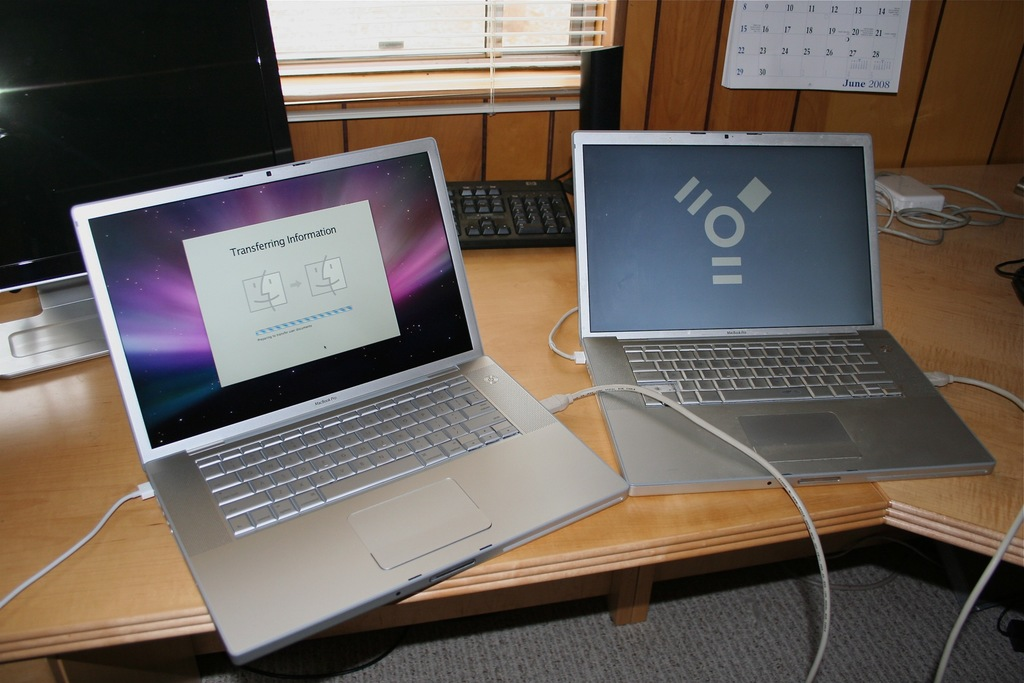Can you tell more about the models of the MacBooks shown in the image? The image displays two older models of Apple MacBook laptops. The one on the left appears to be a MacBook Pro from around 2008, characterized by its silver body and black keyboard, while the other seems to be a variant from a similar era. 